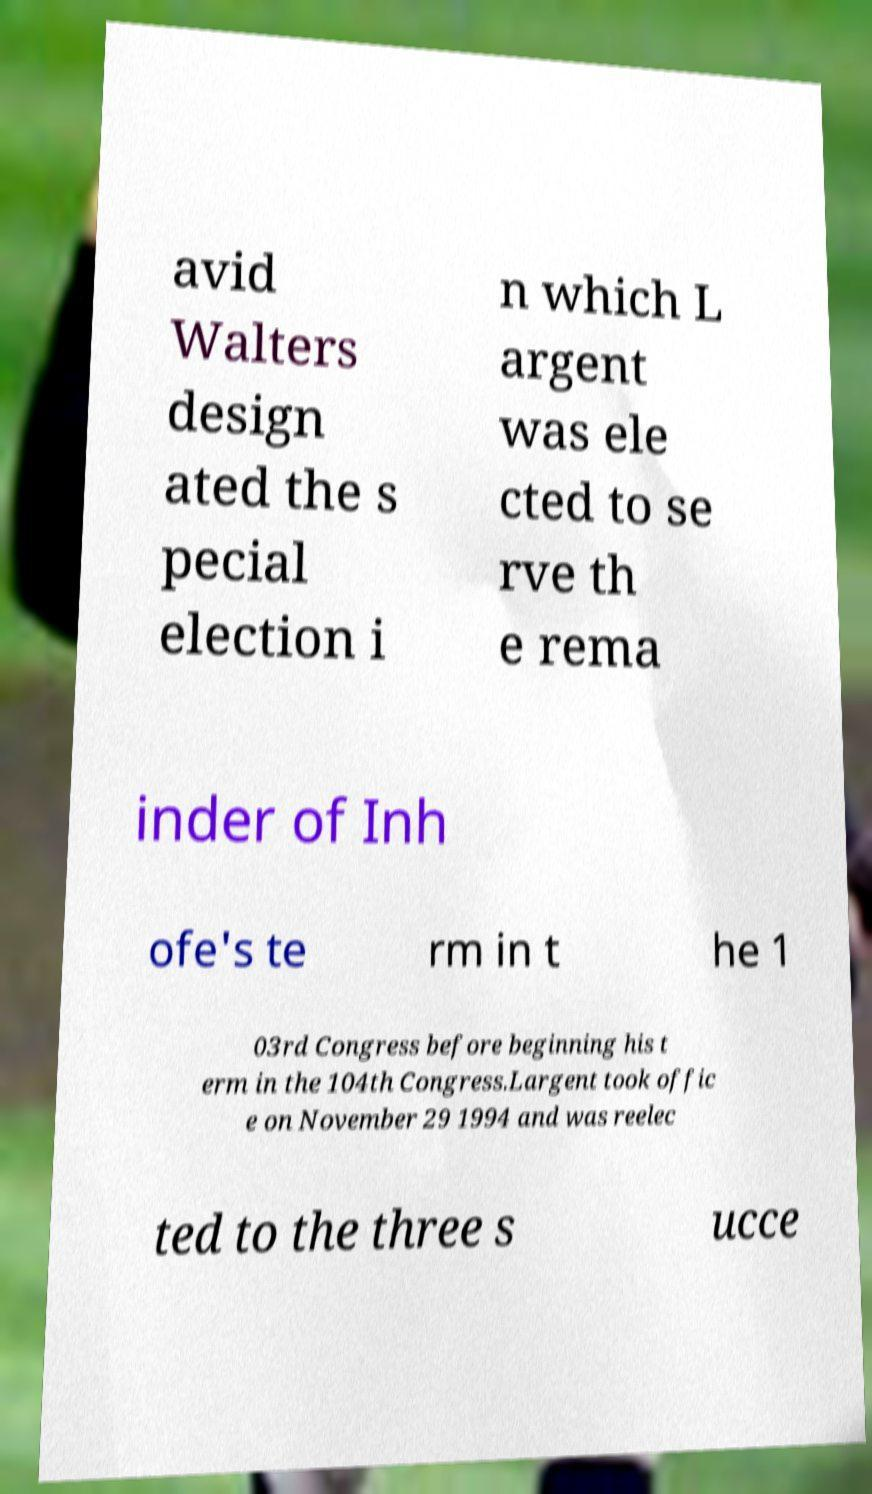Can you read and provide the text displayed in the image?This photo seems to have some interesting text. Can you extract and type it out for me? avid Walters design ated the s pecial election i n which L argent was ele cted to se rve th e rema inder of Inh ofe's te rm in t he 1 03rd Congress before beginning his t erm in the 104th Congress.Largent took offic e on November 29 1994 and was reelec ted to the three s ucce 